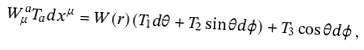Convert formula to latex. <formula><loc_0><loc_0><loc_500><loc_500>W _ { \mu } ^ { a } T _ { a } d x ^ { \mu } = W ( r ) ( T _ { 1 } d \theta + T _ { 2 } \sin \theta d \varphi ) + T _ { 3 } \cos \theta d \varphi \, ,</formula> 